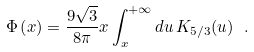<formula> <loc_0><loc_0><loc_500><loc_500>\Phi \left ( x \right ) = \frac { 9 \sqrt { 3 } } { 8 \pi } x \int _ { x } ^ { + \infty } d u \, K _ { 5 / 3 } ( u ) \ .</formula> 